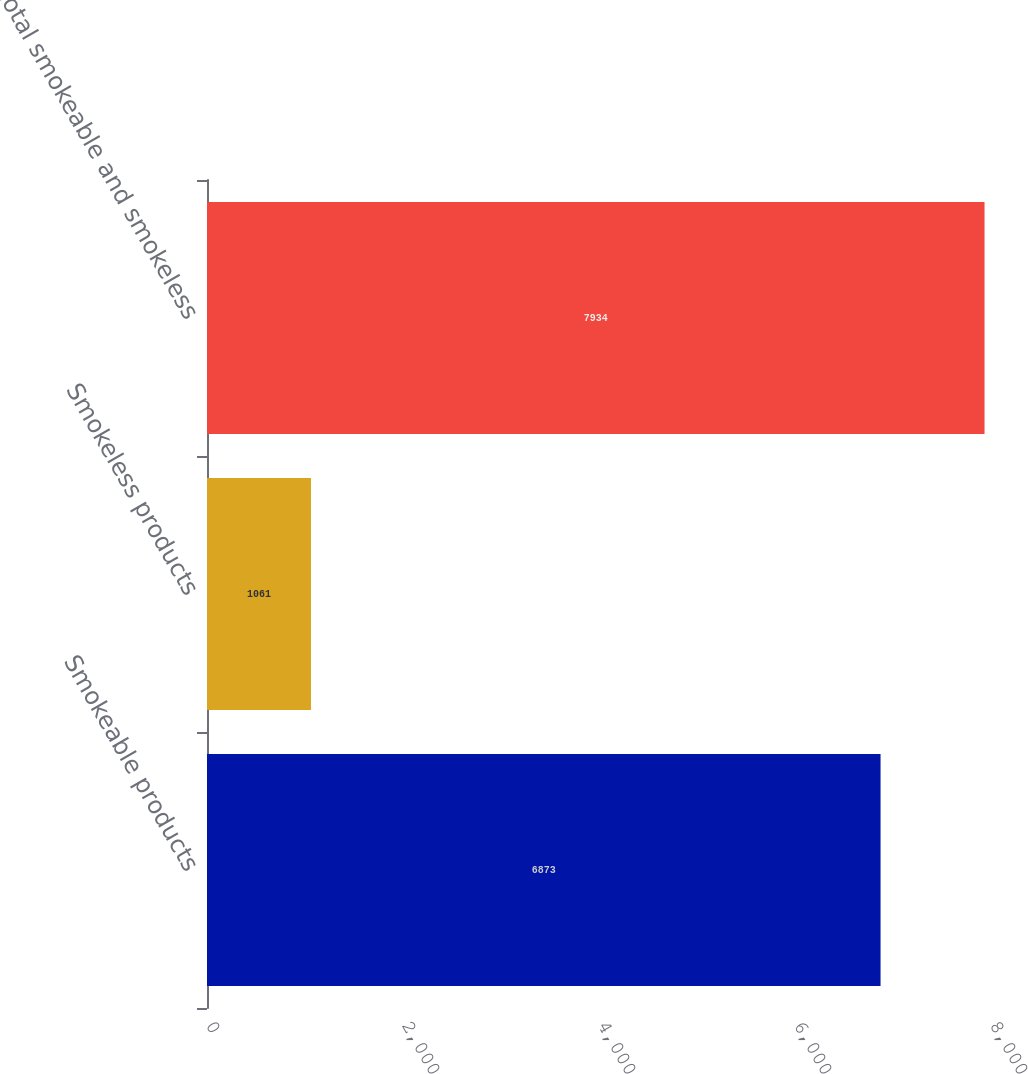<chart> <loc_0><loc_0><loc_500><loc_500><bar_chart><fcel>Smokeable products<fcel>Smokeless products<fcel>Total smokeable and smokeless<nl><fcel>6873<fcel>1061<fcel>7934<nl></chart> 